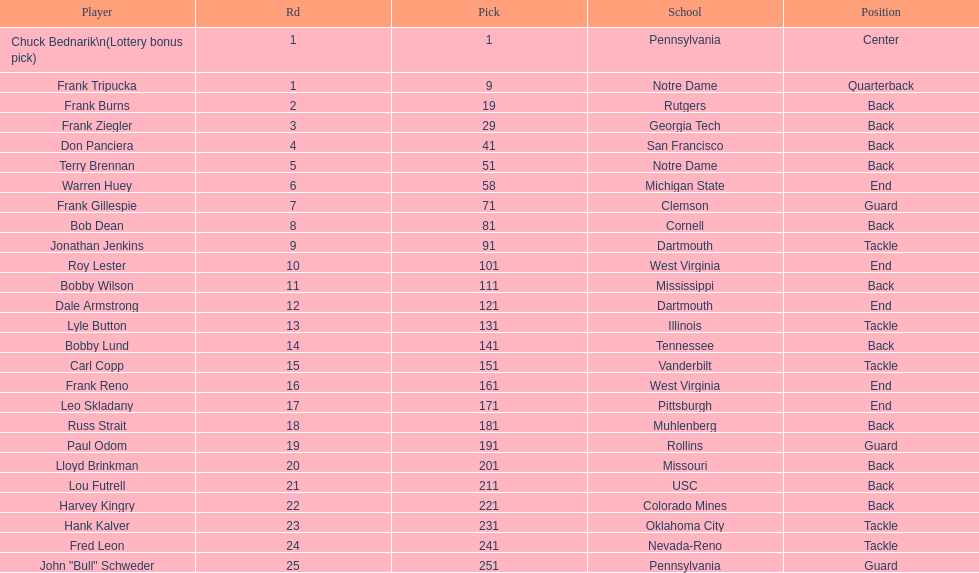Who was picked after roy lester? Bobby Wilson. 